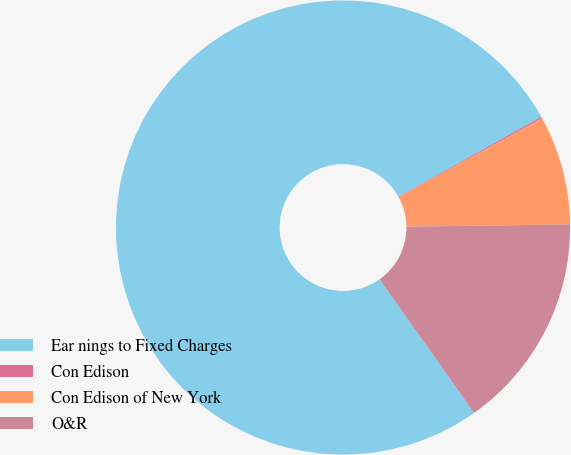<chart> <loc_0><loc_0><loc_500><loc_500><pie_chart><fcel>Ear nings to Fixed Charges<fcel>Con Edison<fcel>Con Edison of New York<fcel>O&R<nl><fcel>76.68%<fcel>0.12%<fcel>7.77%<fcel>15.43%<nl></chart> 